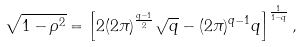Convert formula to latex. <formula><loc_0><loc_0><loc_500><loc_500>\sqrt { 1 - \rho ^ { 2 } } = \left [ 2 ( 2 \pi ) ^ { \frac { q - 1 } { 2 } } \sqrt { q } - ( 2 \pi ) ^ { q - 1 } q \right ] ^ { \frac { 1 } { 1 - q } } ,</formula> 